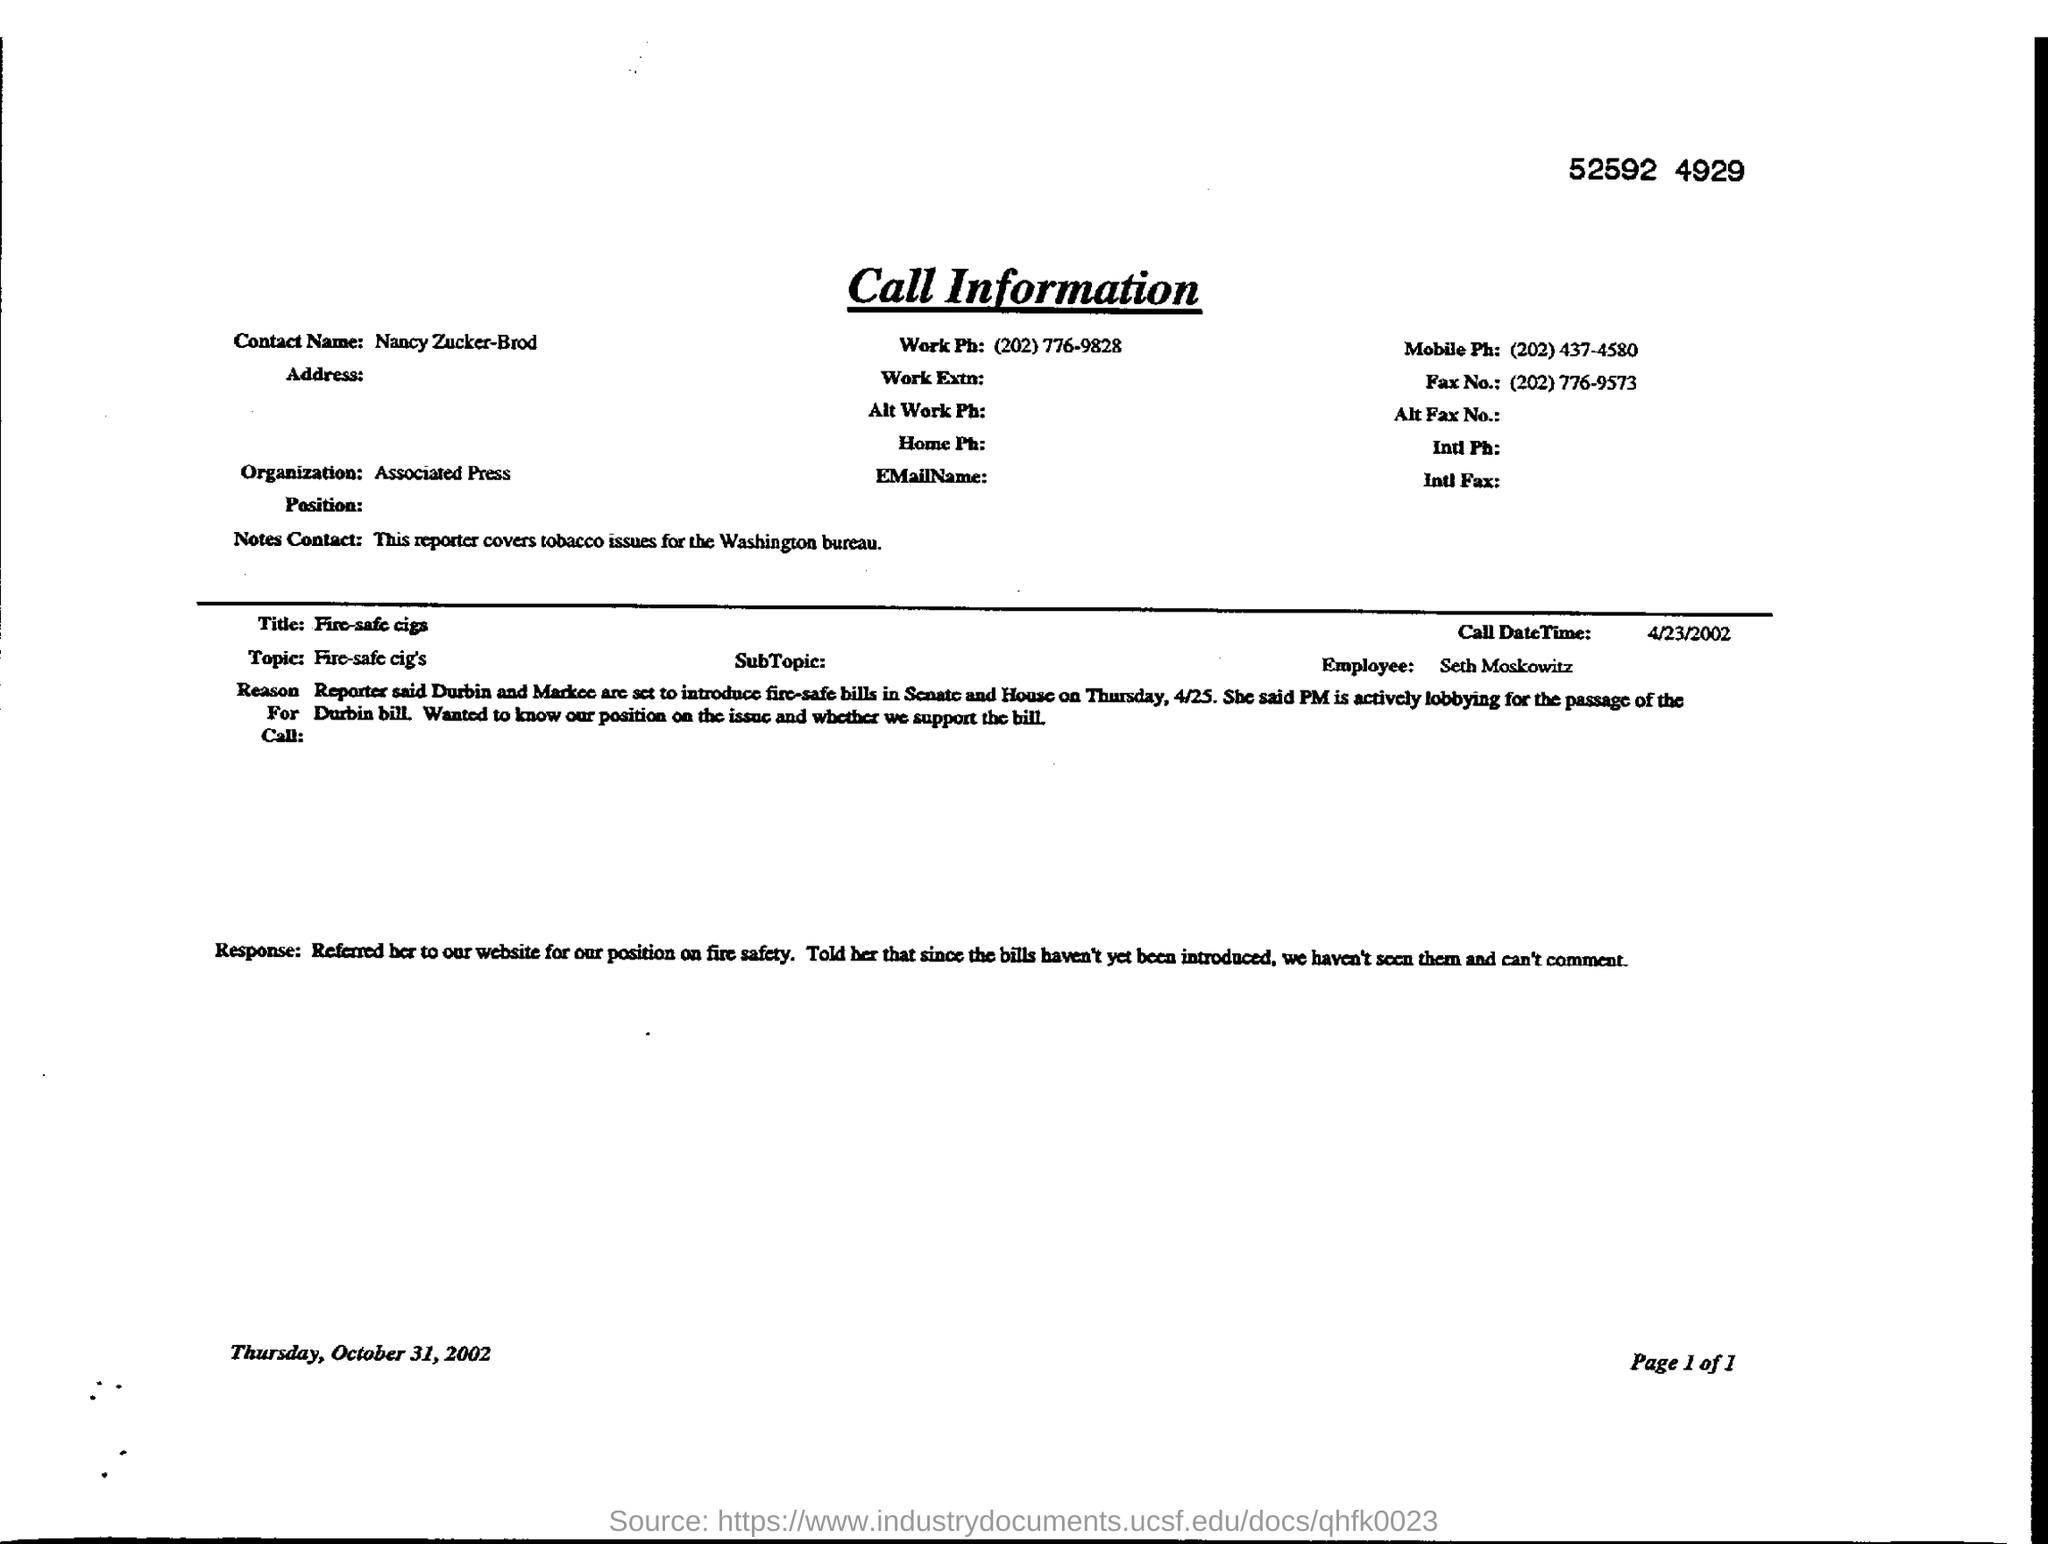What is the contact name mentioned in the document?
Provide a short and direct response. Nancy Zucker-Brod. What is the Mobile phone no of Nancy Zucker-Brod?
Provide a short and direct response. (202) 437-4580. What is the title mentioned in the call information?
Your answer should be very brief. Fire-safe cigs. What is the call date time given?
Provide a succinct answer. 4/23/2002. What is the employee name mentioned in the document?
Make the answer very short. Seth Moskowitz. What is the fax no of Nancy Zucker-Brod?
Your response must be concise. (202) 776-9573. Nancy Zucker-Brod covers what issues for associated press?
Keep it short and to the point. Tobacco issues. Which organization is mentioned in the call information?
Offer a terse response. Associated Press. 